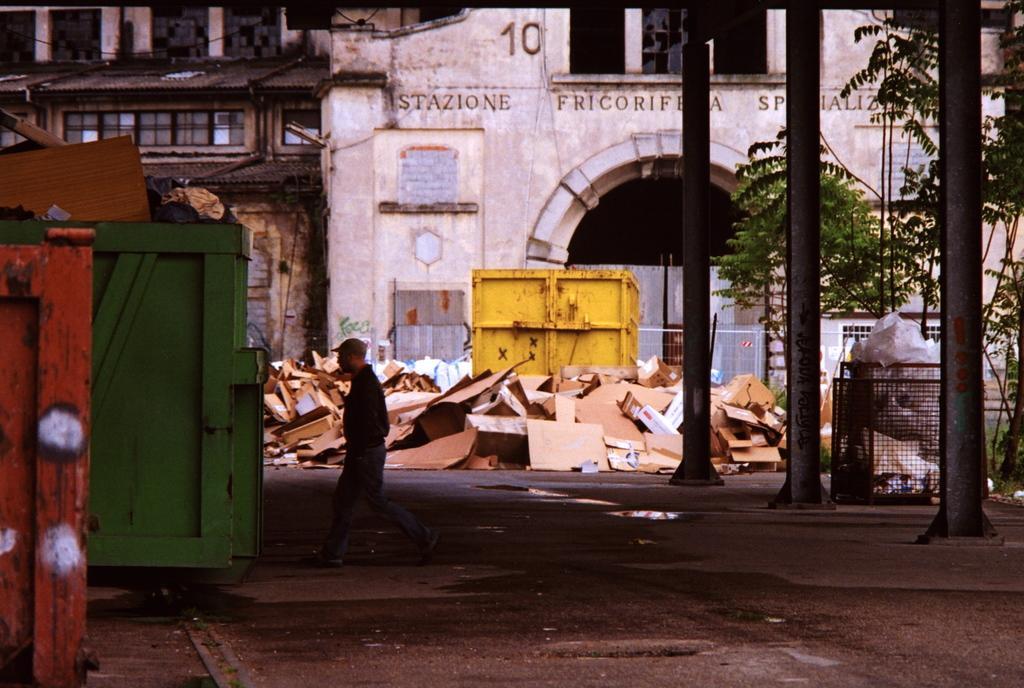Can you describe this image briefly? This is an outside view. At the bottom of the image I can see the road. On the left side there is a green color truck. It is looking like a dustbin. On the right side, I can see few trees and poles. In the background there is a building. In front of this building there are some sheets and a metal box placed on the ground. On the road I can see a person walking towards left side. 